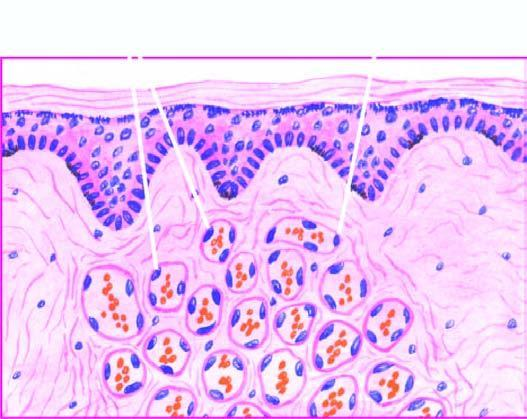does the intervening stroma consist of scant connective tissue?
Answer the question using a single word or phrase. Yes 